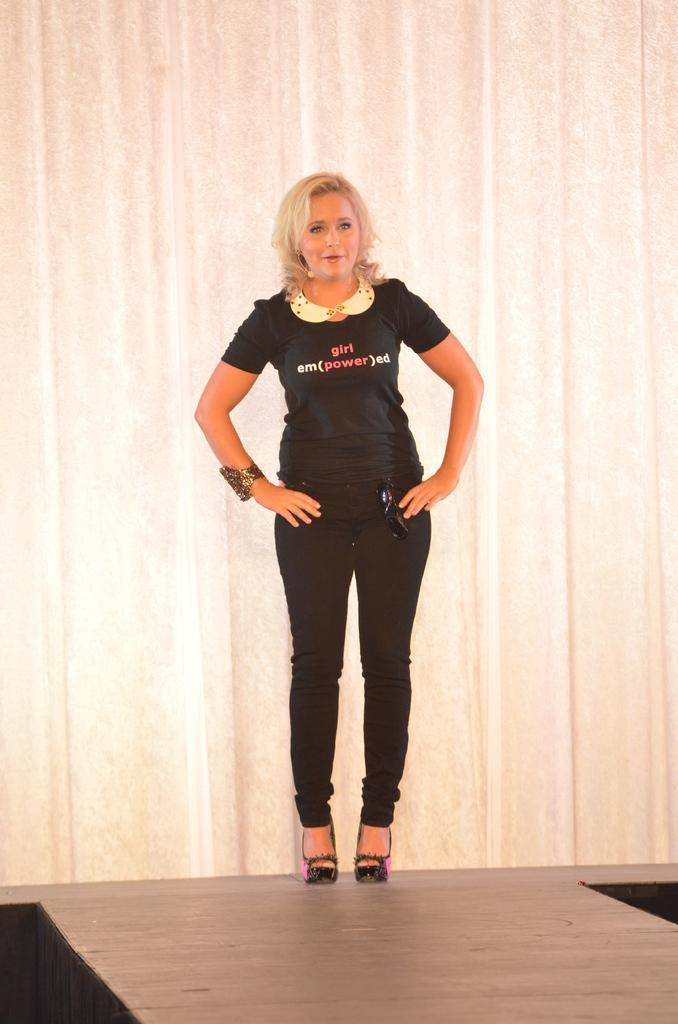Who is present in the image? There is a woman in the image. What is the woman wearing on her upper body? The woman is wearing a black T-shirt. What is the woman wearing on her lower body? The woman is wearing black pants. What type of surface is visible beneath the woman? There is a floor visible in the image. What can be seen behind the woman? There is a wall in the background of the image. What type of finger is the woman wearing in the image? There is no finger mentioned or visible in the image; the woman is wearing a black T-shirt and black pants. 